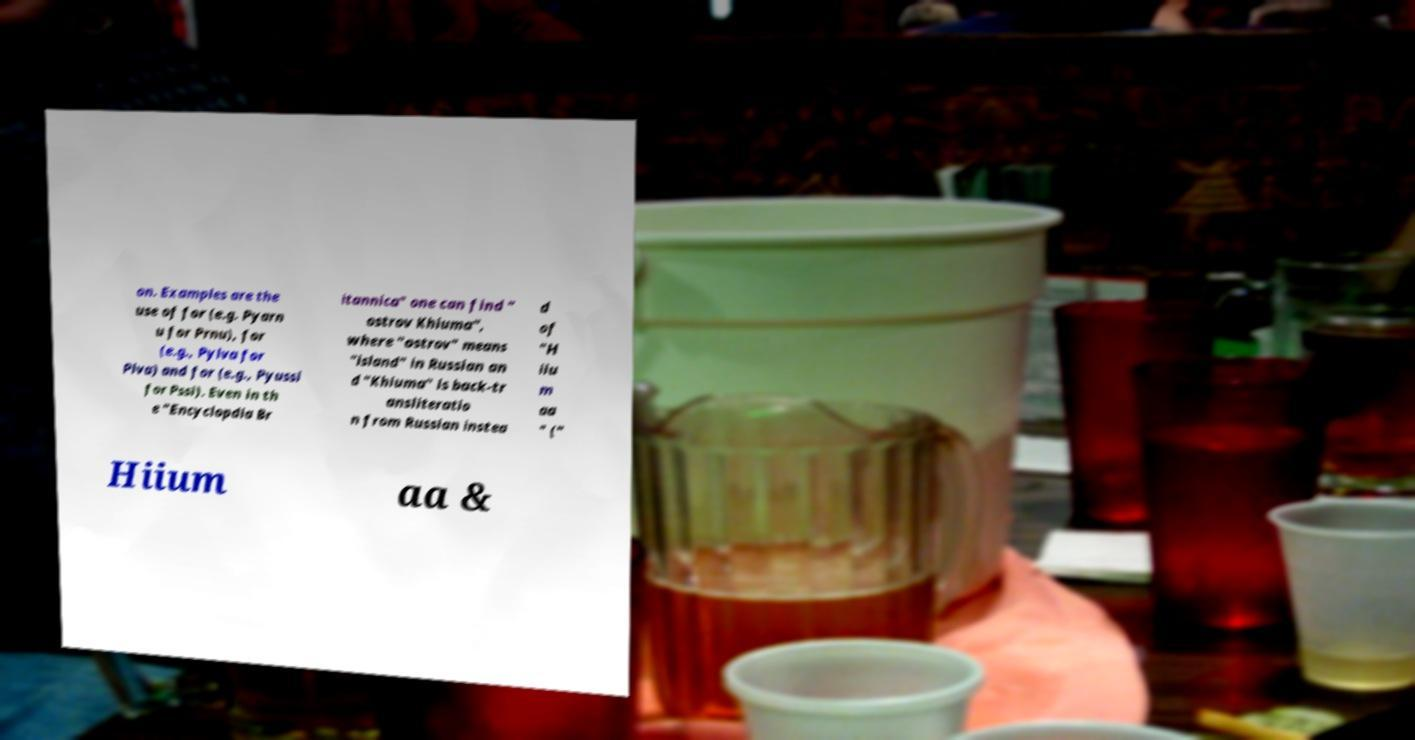There's text embedded in this image that I need extracted. Can you transcribe it verbatim? on. Examples are the use of for (e.g. Pyarn u for Prnu), for (e.g., Pylva for Plva) and for (e.g., Pyussi for Pssi). Even in th e "Encyclopdia Br itannica" one can find " ostrov Khiuma", where "ostrov" means "island" in Russian an d "Khiuma" is back-tr ansliteratio n from Russian instea d of "H iiu m aa " (" Hiium aa & 